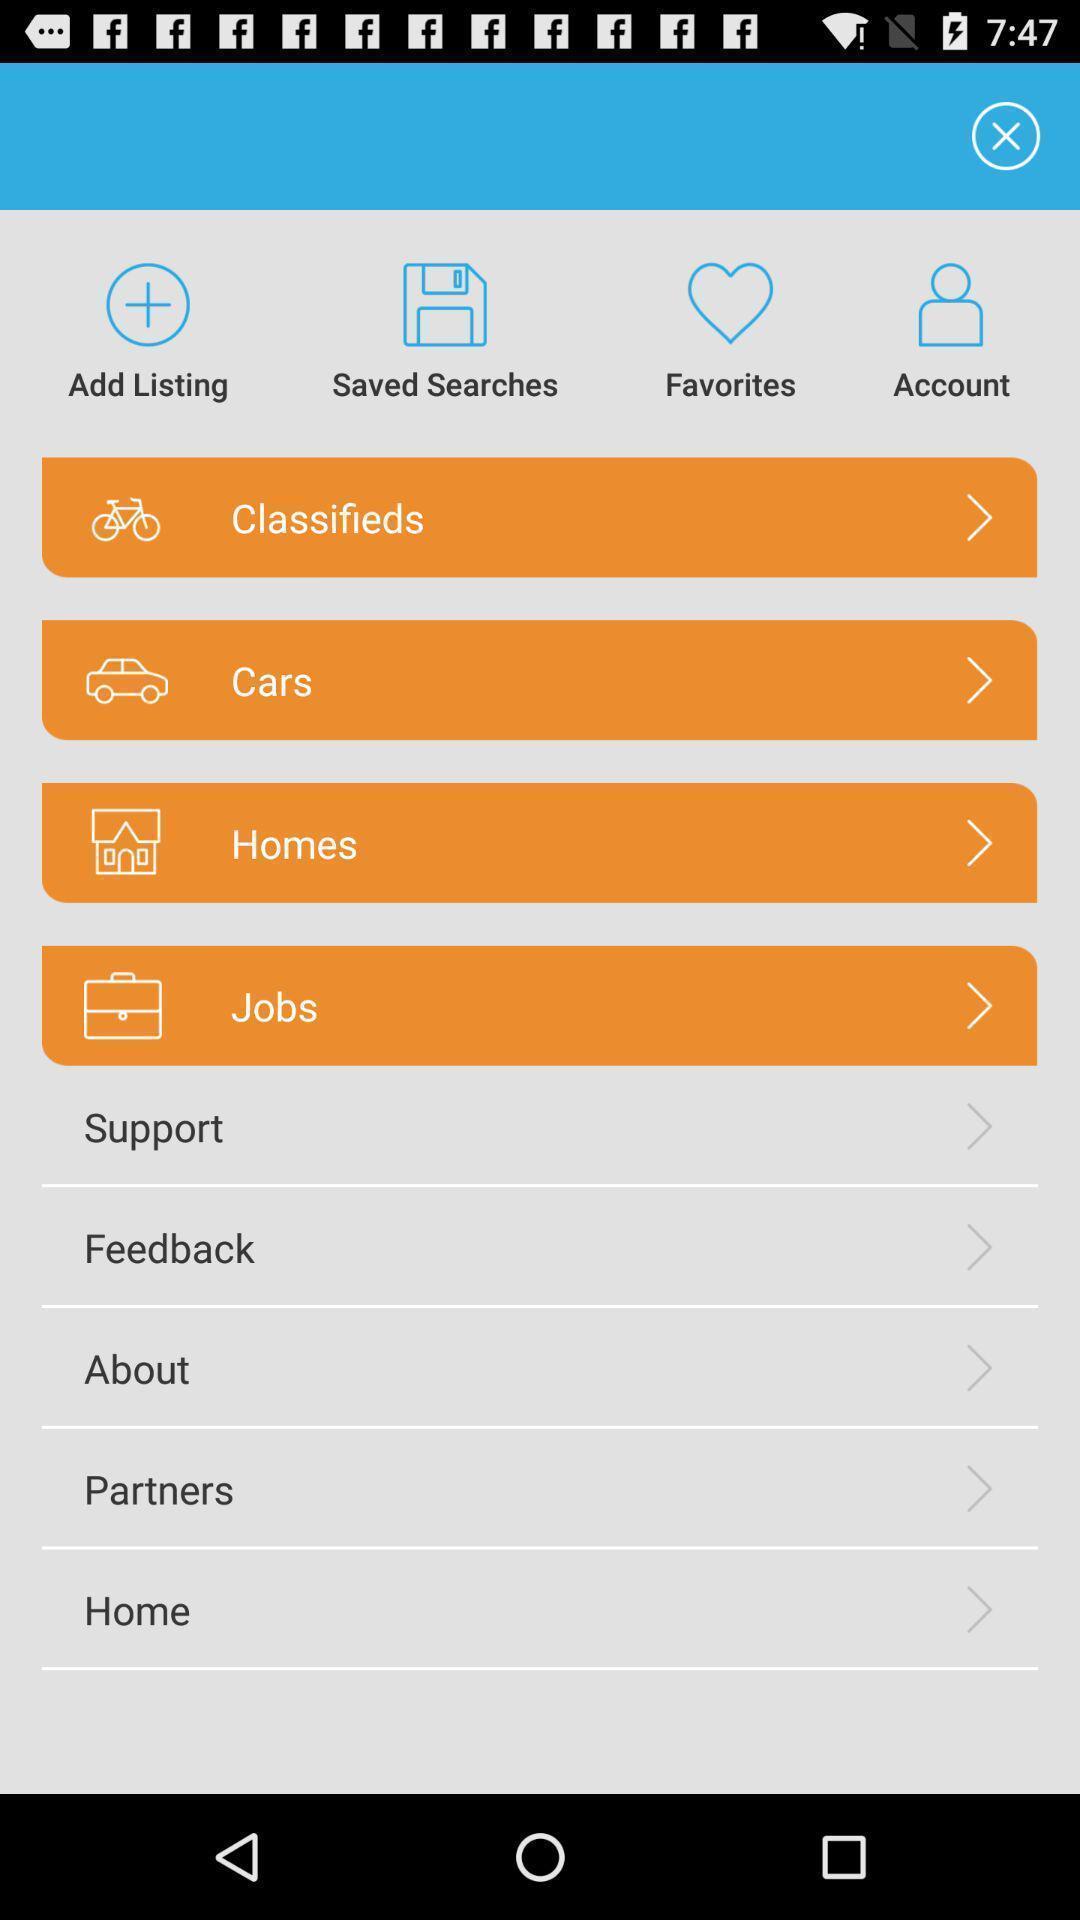Describe the key features of this screenshot. Various options are available in the application. 